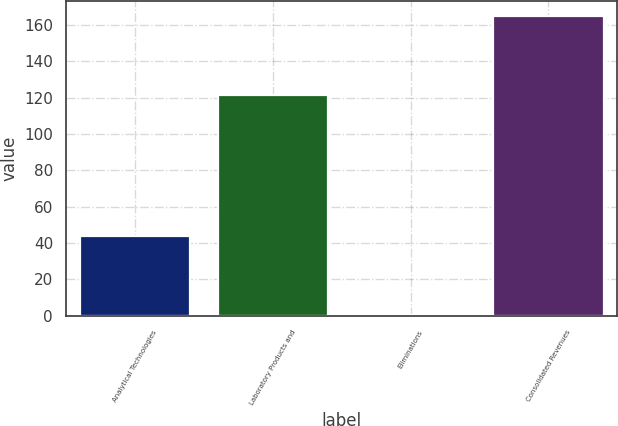Convert chart to OTSL. <chart><loc_0><loc_0><loc_500><loc_500><bar_chart><fcel>Analytical Technologies<fcel>Laboratory Products and<fcel>Eliminations<fcel>Consolidated Revenues<nl><fcel>43.8<fcel>121.4<fcel>0.5<fcel>164.7<nl></chart> 